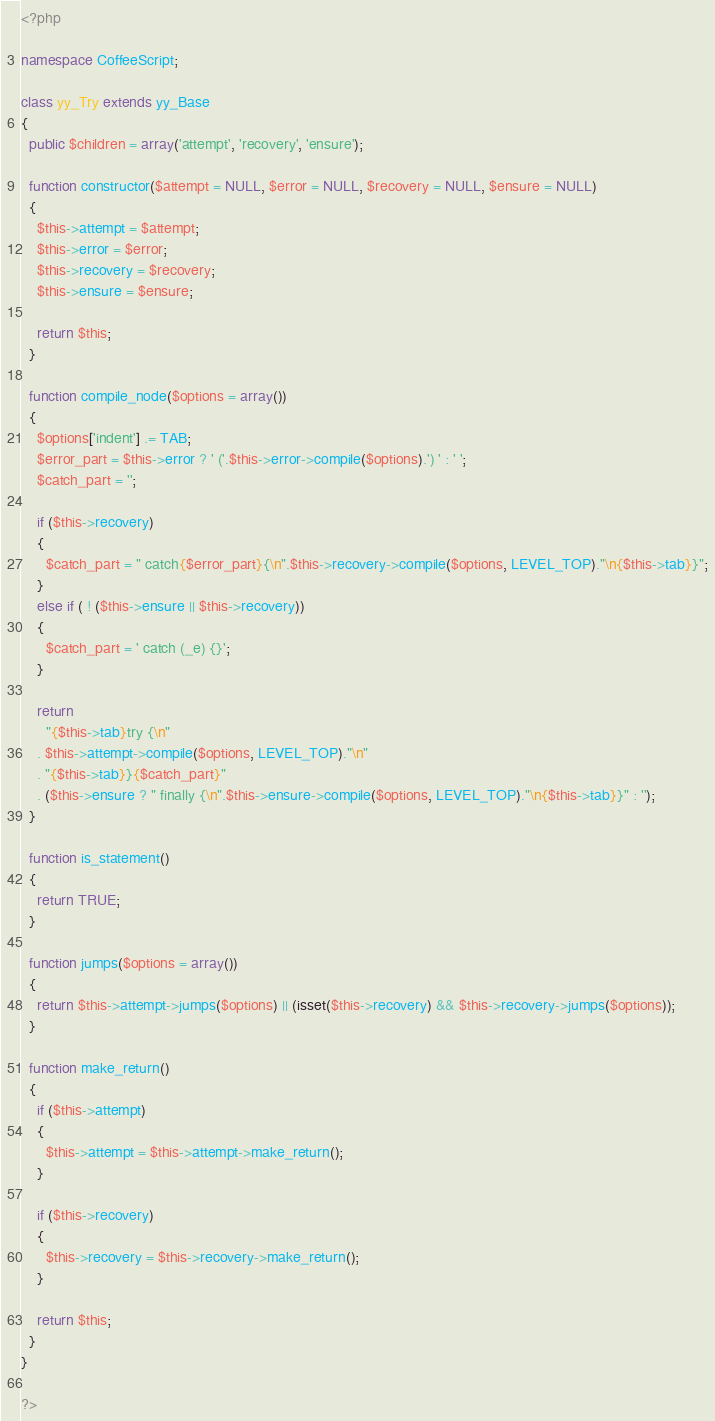<code> <loc_0><loc_0><loc_500><loc_500><_PHP_><?php

namespace CoffeeScript;

class yy_Try extends yy_Base
{
  public $children = array('attempt', 'recovery', 'ensure');

  function constructor($attempt = NULL, $error = NULL, $recovery = NULL, $ensure = NULL)
  {
    $this->attempt = $attempt;
    $this->error = $error;
    $this->recovery = $recovery;
    $this->ensure = $ensure;

    return $this;
  }

  function compile_node($options = array())
  {
    $options['indent'] .= TAB;
    $error_part = $this->error ? ' ('.$this->error->compile($options).') ' : ' ';
    $catch_part = '';

    if ($this->recovery)
    {
      $catch_part = " catch{$error_part}{\n".$this->recovery->compile($options, LEVEL_TOP)."\n{$this->tab}}";
    }
    else if ( ! ($this->ensure || $this->recovery))
    {
      $catch_part = ' catch (_e) {}';
    }

    return
      "{$this->tab}try {\n"
    . $this->attempt->compile($options, LEVEL_TOP)."\n"
    . "{$this->tab}}{$catch_part}"
    . ($this->ensure ? " finally {\n".$this->ensure->compile($options, LEVEL_TOP)."\n{$this->tab}}" : '');
  }

  function is_statement()
  {
    return TRUE;
  }

  function jumps($options = array())
  {
    return $this->attempt->jumps($options) || (isset($this->recovery) && $this->recovery->jumps($options));
  }

  function make_return()
  {
    if ($this->attempt)
    {
      $this->attempt = $this->attempt->make_return();
    }

    if ($this->recovery)
    {
      $this->recovery = $this->recovery->make_return();
    }

    return $this;
  }
}

?>
</code> 